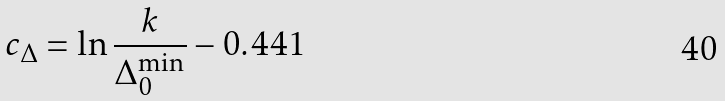<formula> <loc_0><loc_0><loc_500><loc_500>c _ { \Delta } = \ln \frac { k } { \Delta _ { 0 } ^ { \min } } - 0 . 4 4 1</formula> 